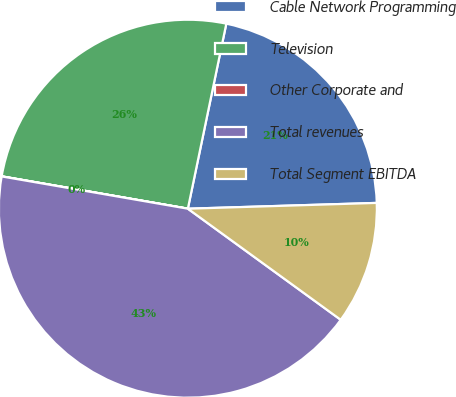<chart> <loc_0><loc_0><loc_500><loc_500><pie_chart><fcel>Cable Network Programming<fcel>Television<fcel>Other Corporate and<fcel>Total revenues<fcel>Total Segment EBITDA<nl><fcel>21.25%<fcel>25.52%<fcel>0.01%<fcel>42.73%<fcel>10.49%<nl></chart> 